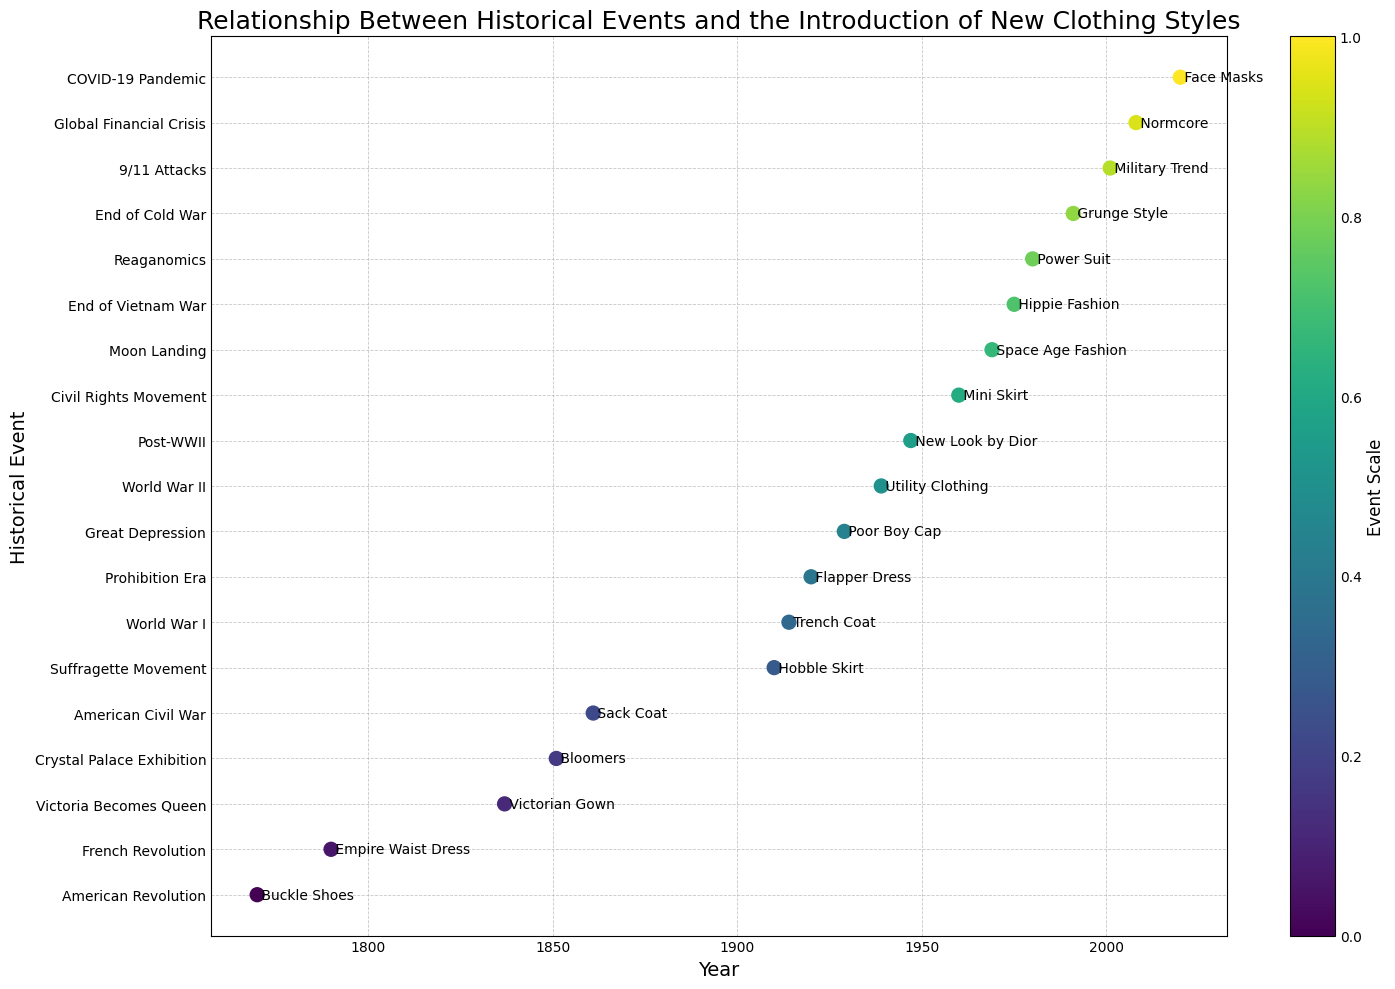Which historical event has the earliest associated clothing style introduction? The scatter plot places the events along the x-axis in chronological order. The earliest point corresponds to the earliest year, which is 1770.
Answer: American Revolution Which clothing style was introduced in association with the Moon Landing? Look for the event labeled "Moon Landing" on the y-axis, and observe the associated text on the point directly on the x-axis.
Answer: Space Age Fashion Compare the time interval between the introductions of the Trench Coat and the Flapper Dress with the interval between Utility Clothing and the New Look by Dior. Which interval is shorter? First, identify the years for each style: Trench Coat (1914), Flapper Dress (1920), Utility Clothing (1939), New Look by Dior (1947). Then, calculate the intervals: Trench Coat to Flapper Dress is 1920 - 1914 = 6 years; Utility Clothing to New Look by Dior is 1947 - 1939 = 8 years.
Answer: Trench Coat and Flapper Dress Which event is closest in time to the COVID-19 Pandemic? Identify the years of the COVID-19 pandemic (2020) and compare it with the adjacent points in time. The point right before 2020 is 2008, and the event is the Global Financial Crisis.
Answer: Global Financial Crisis What kind of visual pattern is used to display the sequence of events over time in the scatter plot? By observing the scatter plot, events are ordered along the horizontal axis, and the colors represent a gradient from one end to the other.
Answer: Gradient sequence What was the clothing style introduction during the French Revolution? Locate the event labeled "French Revolution" on the y-axis of the plot and read the associated clothing style written next to the point.
Answer: Empire Waist Dress How many years are there between the introduction of the Buckle Shoes and the Space Age Fashion? Identify the years for Buckle Shoes (1770) and Space Age Fashion (1969). Subtract the former from the latter: 1969 - 1770 = 199 years.
Answer: 199 years During which event was the Power Suit introduced? Find the Power Suit label next to the respective point on the scatter plot and look to its horizontal position to determine the associated event.
Answer: Reaganomics What is the color trend used to represent events from the American Revolution to the COVID-19 Pandemic? Visual observation indicates a color gradient trend progressing from one end of the plot to the other, indicating a continuum of chronological progression.
Answer: Gradient from one color to another Are there any two clothing styles introduced at the same event? Observing the scatter plot, each point is tied to a unique event and a unique style, meaning no two styles were introduced at the same event.
Answer: No 